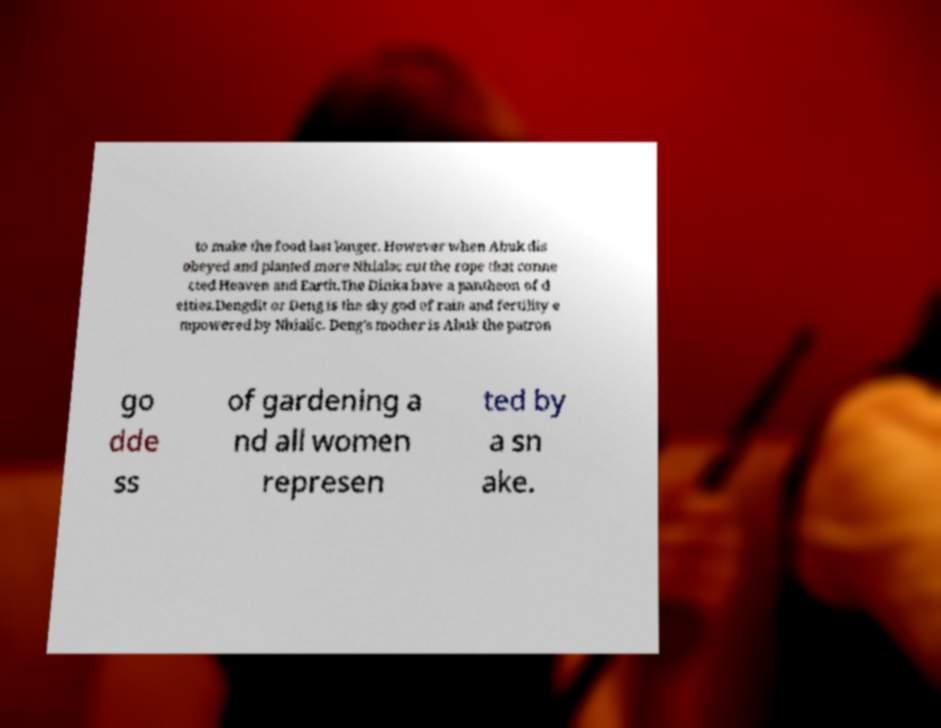Can you accurately transcribe the text from the provided image for me? to make the food last longer. However when Abuk dis obeyed and planted more Nhialac cut the rope that conne cted Heaven and Earth.The Dinka have a pantheon of d eities.Dengdit or Deng is the sky god of rain and fertility e mpowered by Nhialic. Deng's mother is Abuk the patron go dde ss of gardening a nd all women represen ted by a sn ake. 